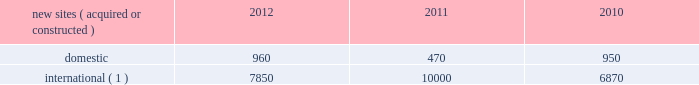Continue to be deployed as wireless service providers are beginning their investments in 3g data networks .
Similarly , in ghana and uganda , wireless service providers continue to build out their voice and data networks in order to satisfy increasing demand for wireless services .
In south africa , where voice networks are in a more advanced stage of development , carriers are beginning to deploy 3g data networks across spectrum acquired in recent spectrum auctions .
In mexico and brazil , where nationwide voice networks have also been deployed , some incumbent wireless service providers continue to invest in their 3g data networks , and recent spectrum auctions have enabled other incumbent wireless service providers to begin their initial investments in 3g data networks .
In markets such as chile , peru and colombia , recent or anticipated spectrum auctions are expected to drive investment in nationwide voice and 3g data networks .
In germany , our most mature international wireless market , demand is currently being driven by a government-mandated rural fourth generation network build-out , as well as other tenant initiatives to deploy next generation wireless services .
We believe incremental demand for our tower sites will continue in our international markets as wireless service providers seek to remain competitive by increasing the coverage of their networks while also investing in next generation data networks .
Rental and management operations new site revenue growth .
During the year ended december 31 , 2012 , we grew our portfolio of communications real estate through acquisitions and construction activities , including the acquisition and construction of approximately 8810 sites .
In a majority of our international markets , the acquisition or construction of new sites results in increased pass-through revenues and expenses .
We continue to evaluate opportunities to acquire larger communications real estate portfolios , both domestically and internationally , to determine whether they meet our risk adjusted hurdle rates and whether we believe we can effectively integrate them into our existing portfolio. .
( 1 ) the majority of sites acquired or constructed in 2012 were in brazil , germany , india and uganda ; in 2011 were in brazil , colombia , ghana , india , mexico and south africa ; and in 2010 were in chile , colombia , india and peru .
Network development services segment revenue growth .
As we continue to focus on growing our rental and management operations , we anticipate that our network development services revenue will continue to represent a relatively small percentage of our total revenues .
Through our network development services segment , we offer tower-related services , including site acquisition , zoning and permitting services and structural analysis services , which primarily support our site leasing business and the addition of new tenants and equipment on our sites , including in connection with provider network upgrades .
Rental and management operations expenses .
Direct operating expenses incurred by our domestic and international rental and management segments include direct site level expenses and consist primarily of ground rent , property taxes , repairs and maintenance , security and power and fuel costs , some of which may be passed through to our tenants .
These segment direct operating expenses exclude all segment and corporate selling , general , administrative and development expenses , which are aggregated into one line item entitled selling , general , administrative and development expense in our consolidated statements of operations .
In general , our domestic and international rental and management segments selling , general , administrative and development expenses do not significantly increase as a result of adding incremental tenants to our legacy sites and typically increase only modestly year-over-year .
As a result , leasing additional space to new tenants on our legacy sites provides significant incremental cash flow .
We may incur additional segment selling , general , administrative and development expenses as we increase our presence in geographic areas where we have recently launched operations or are focused on expanding our portfolio .
Our profit margin growth is therefore positively impacted by the addition of new tenants to our legacy sites and can be temporarily diluted by our development activities. .
In 2011 , what percent of new sites were foreign? 
Computations: (1000 / (470 + 1000))
Answer: 0.68027. 